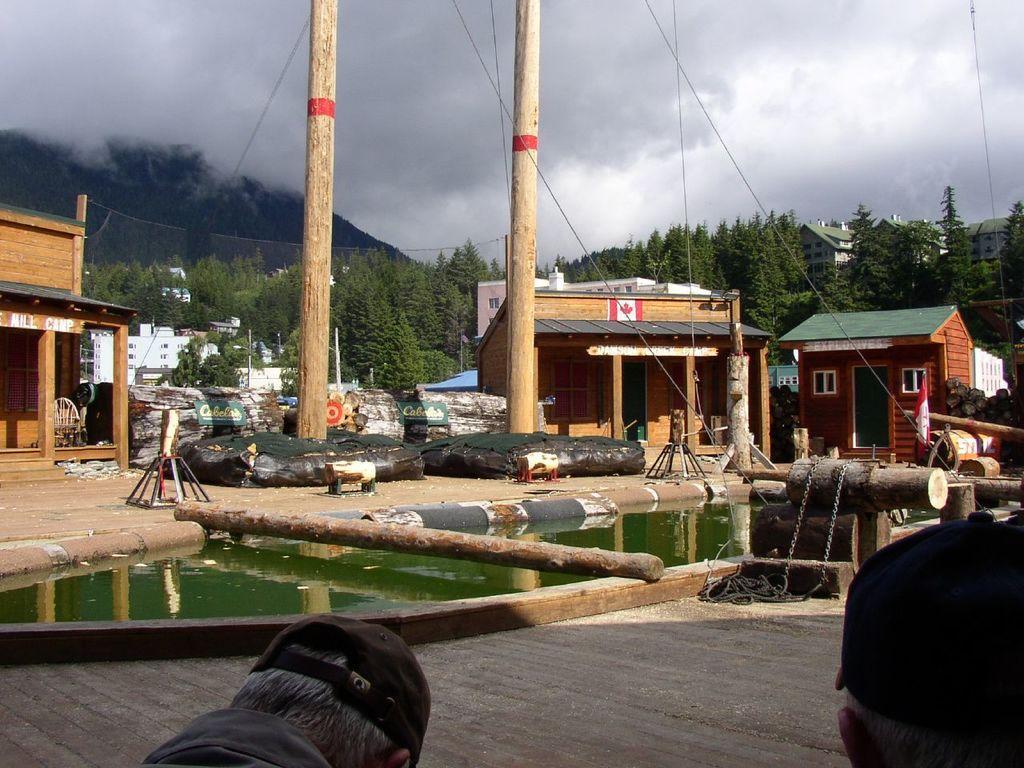Please provide a concise description of this image. In the foreground of this picture, there are heads of a person, water, a trunk two poles and houses. Mountain, trees and the cloud are in the background. 